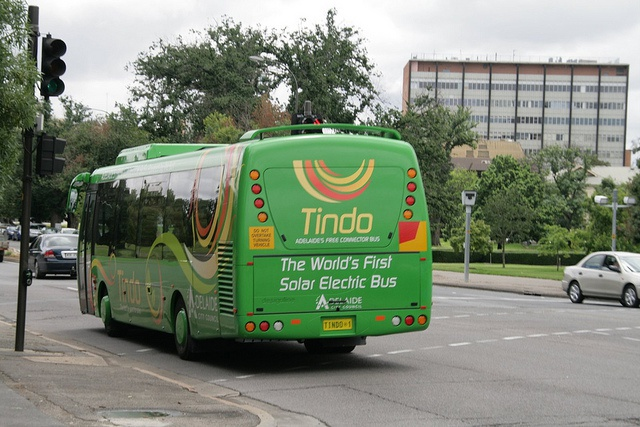Describe the objects in this image and their specific colors. I can see bus in darkgreen, green, and black tones, car in darkgreen, darkgray, lightgray, gray, and black tones, car in darkgreen, black, darkgray, gray, and lightgray tones, traffic light in darkgreen, black, lightgray, gray, and darkgray tones, and traffic light in darkgreen, black, and gray tones in this image. 